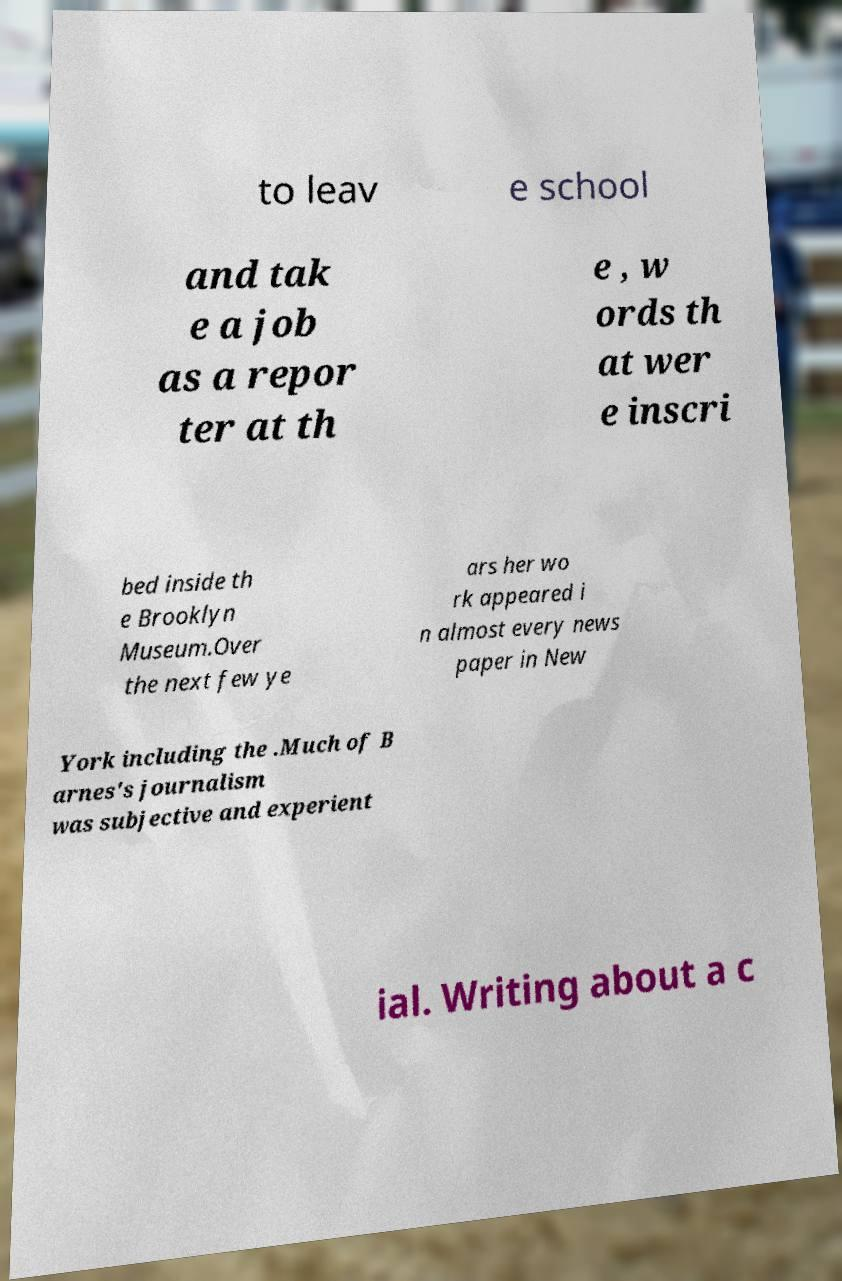For documentation purposes, I need the text within this image transcribed. Could you provide that? to leav e school and tak e a job as a repor ter at th e , w ords th at wer e inscri bed inside th e Brooklyn Museum.Over the next few ye ars her wo rk appeared i n almost every news paper in New York including the .Much of B arnes's journalism was subjective and experient ial. Writing about a c 